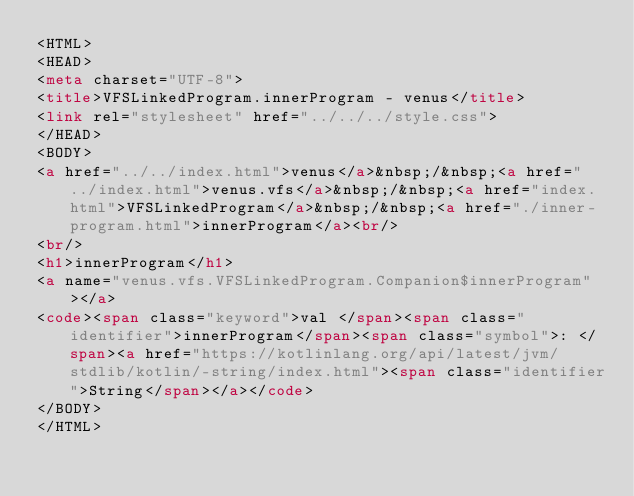<code> <loc_0><loc_0><loc_500><loc_500><_HTML_><HTML>
<HEAD>
<meta charset="UTF-8">
<title>VFSLinkedProgram.innerProgram - venus</title>
<link rel="stylesheet" href="../../../style.css">
</HEAD>
<BODY>
<a href="../../index.html">venus</a>&nbsp;/&nbsp;<a href="../index.html">venus.vfs</a>&nbsp;/&nbsp;<a href="index.html">VFSLinkedProgram</a>&nbsp;/&nbsp;<a href="./inner-program.html">innerProgram</a><br/>
<br/>
<h1>innerProgram</h1>
<a name="venus.vfs.VFSLinkedProgram.Companion$innerProgram"></a>
<code><span class="keyword">val </span><span class="identifier">innerProgram</span><span class="symbol">: </span><a href="https://kotlinlang.org/api/latest/jvm/stdlib/kotlin/-string/index.html"><span class="identifier">String</span></a></code>
</BODY>
</HTML>
</code> 